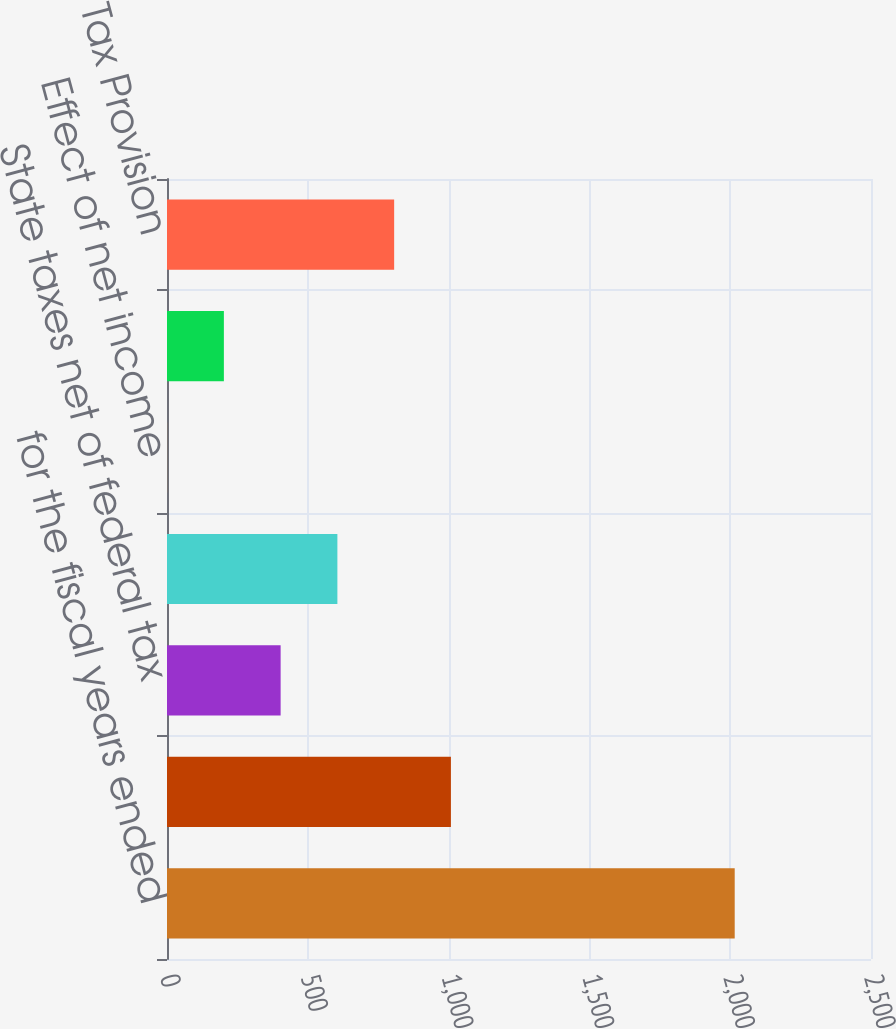<chart> <loc_0><loc_0><loc_500><loc_500><bar_chart><fcel>for the fiscal years ended<fcel>Federal taxes at statutory<fcel>State taxes net of federal tax<fcel>Effect of non-US operations<fcel>Effect of net income<fcel>Other<fcel>Tax Provision<nl><fcel>2016<fcel>1008.2<fcel>403.52<fcel>605.08<fcel>0.4<fcel>201.96<fcel>806.64<nl></chart> 